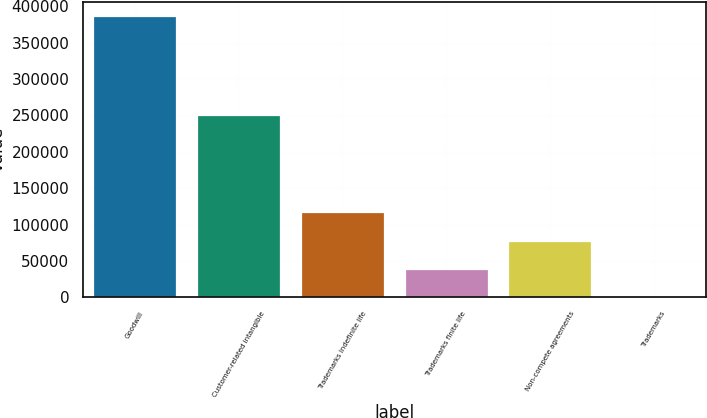Convert chart to OTSL. <chart><loc_0><loc_0><loc_500><loc_500><bar_chart><fcel>Goodwill<fcel>Customer-related intangible<fcel>Trademarks indefinite life<fcel>Trademarks finite life<fcel>Non-compete agreements<fcel>Trademarks<nl><fcel>387280<fcel>250886<fcel>116647<fcel>39322.9<fcel>77984.8<fcel>661<nl></chart> 